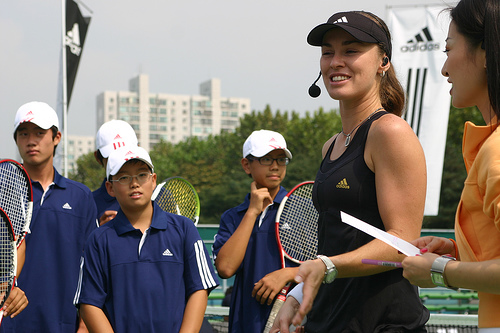<image>
Is the bat behind the woman? Yes. From this viewpoint, the bat is positioned behind the woman, with the woman partially or fully occluding the bat. 